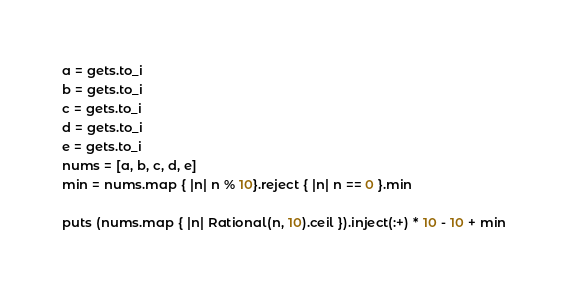<code> <loc_0><loc_0><loc_500><loc_500><_Ruby_>a = gets.to_i
b = gets.to_i
c = gets.to_i
d = gets.to_i
e = gets.to_i
nums = [a, b, c, d, e]
min = nums.map { |n| n % 10}.reject { |n| n == 0 }.min

puts (nums.map { |n| Rational(n, 10).ceil }).inject(:+) * 10 - 10 + min</code> 